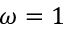Convert formula to latex. <formula><loc_0><loc_0><loc_500><loc_500>\omega = 1</formula> 